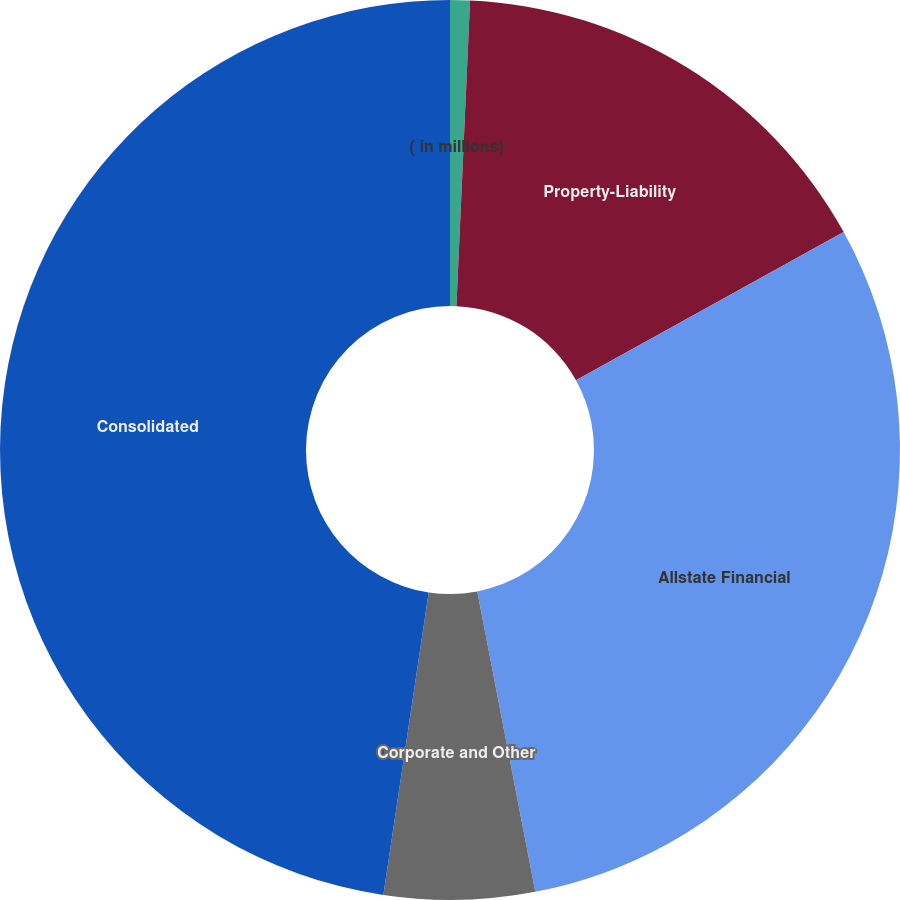Convert chart. <chart><loc_0><loc_0><loc_500><loc_500><pie_chart><fcel>( in millions)<fcel>Property-Liability<fcel>Allstate Financial<fcel>Corporate and Other<fcel>Consolidated<nl><fcel>0.71%<fcel>16.24%<fcel>30.01%<fcel>5.4%<fcel>47.63%<nl></chart> 